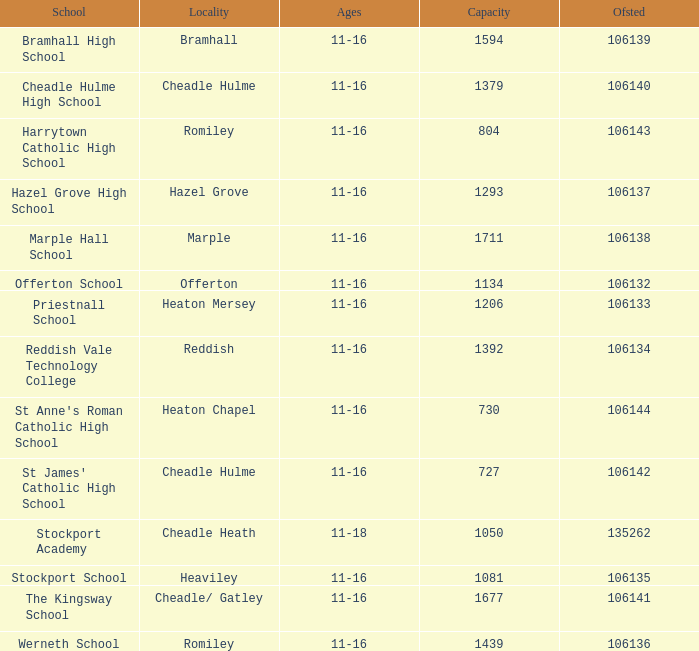Parse the table in full. {'header': ['School', 'Locality', 'Ages', 'Capacity', 'Ofsted'], 'rows': [['Bramhall High School', 'Bramhall', '11-16', '1594', '106139'], ['Cheadle Hulme High School', 'Cheadle Hulme', '11-16', '1379', '106140'], ['Harrytown Catholic High School', 'Romiley', '11-16', '804', '106143'], ['Hazel Grove High School', 'Hazel Grove', '11-16', '1293', '106137'], ['Marple Hall School', 'Marple', '11-16', '1711', '106138'], ['Offerton School', 'Offerton', '11-16', '1134', '106132'], ['Priestnall School', 'Heaton Mersey', '11-16', '1206', '106133'], ['Reddish Vale Technology College', 'Reddish', '11-16', '1392', '106134'], ["St Anne's Roman Catholic High School", 'Heaton Chapel', '11-16', '730', '106144'], ["St James' Catholic High School", 'Cheadle Hulme', '11-16', '727', '106142'], ['Stockport Academy', 'Cheadle Heath', '11-18', '1050', '135262'], ['Stockport School', 'Heaviley', '11-16', '1081', '106135'], ['The Kingsway School', 'Cheadle/ Gatley', '11-16', '1677', '106141'], ['Werneth School', 'Romiley', '11-16', '1439', '106136']]} In heaton mersey, which school can hold over 730 students, has an ofsted score less than 106135? Priestnall School. 